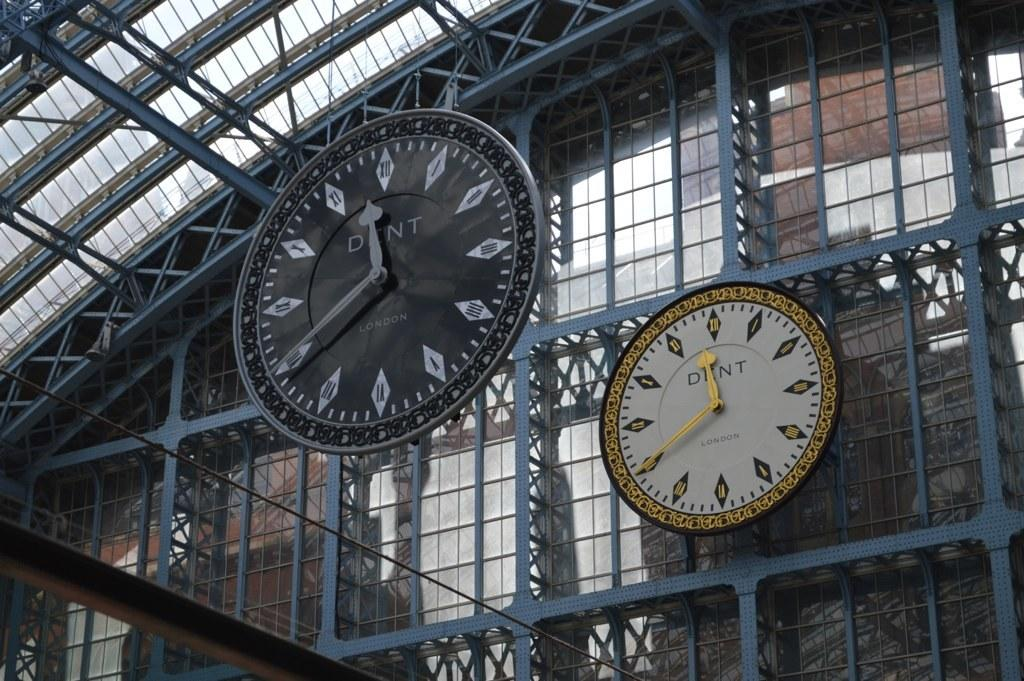What type of structure is present in the image? There is a building in the image. What can be seen near the building? There is a metal fence in the image. How many clocks are visible in the image? There are at least two clocks visible in the image. What type of dust can be seen on the clocks in the image? There is no dust visible on the clocks in the image. 